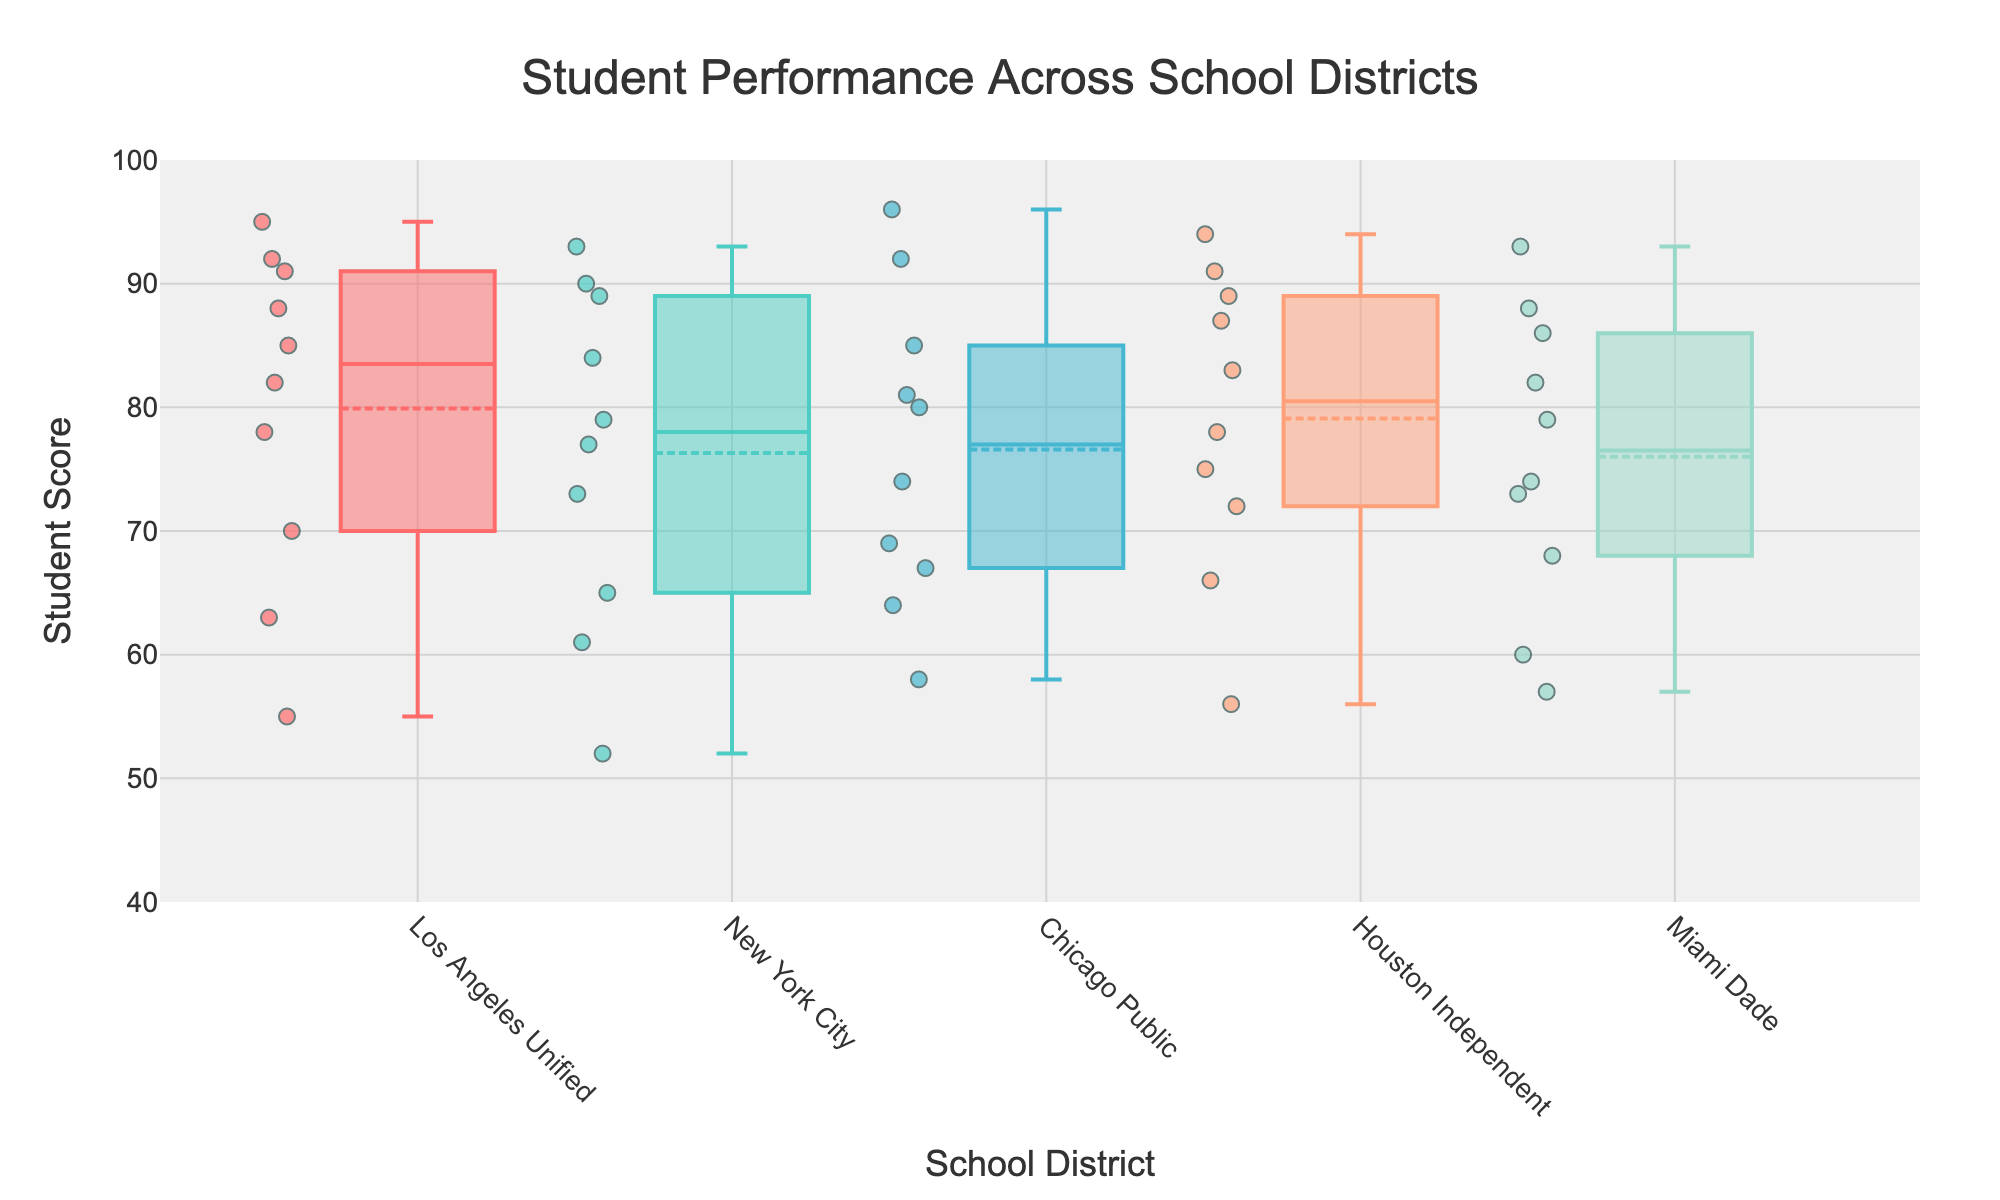Which school district has the highest median student score? To determine this, first look at the line in the center of each box, which represents the median value. Compare these lines for all the districts shown in the figure.
Answer: Chicago Public What is the title of the plot? The title is typically positioned at the top center of the plot and is designed to give a succinct insight into the purpose of the visualization.
Answer: Student Performance Across School Districts How many school districts are represented in the plot? The x-axis denotes the different school districts, each represented by a separate box plot. Count the distinct names shown on this axis.
Answer: 5 Which two school districts have the largest interquartile range (IQR)? The IQR is the range between the top and bottom edges of the box. To answer this, identify which two districts have the tallest boxes.
Answer: Los Angeles Unified and New York City What is the minimum student score in the Chicago Public school district? Look for the lowest point (the bottom whisker or the lowest point of any outliers) in the box plot for Chicago Public.
Answer: 58 Which school district has the most outliers? Outliers are individual data points shown away from the whiskers or main box. Count these points for each district and determine which has the greatest number.
Answer: Houston Independent Between Houston Independent and Miami Dade, which district has a higher third quartile (Q3)? The third quartile is represented by the top edge of the box. Compare the heights of these edges between Houston Independent and Miami Dade.
Answer: Houston Independent What is the highest student score observed across all districts? Identify the highest point in the plot, which includes both the whiskers and any outliers that may extend above.
Answer: 96 What is the range of student scores in New York City? The range is the difference between the highest and lowest scores. Identify the top and bottom of the whiskers (or any outliers if they exist) and calculate the difference.
Answer: 93 - 52 = 41 Which district has the smallest median student score? Find the box with the lowest center line representing the median and compare it across all districts.
Answer: New York City 